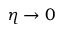<formula> <loc_0><loc_0><loc_500><loc_500>\eta \to 0</formula> 